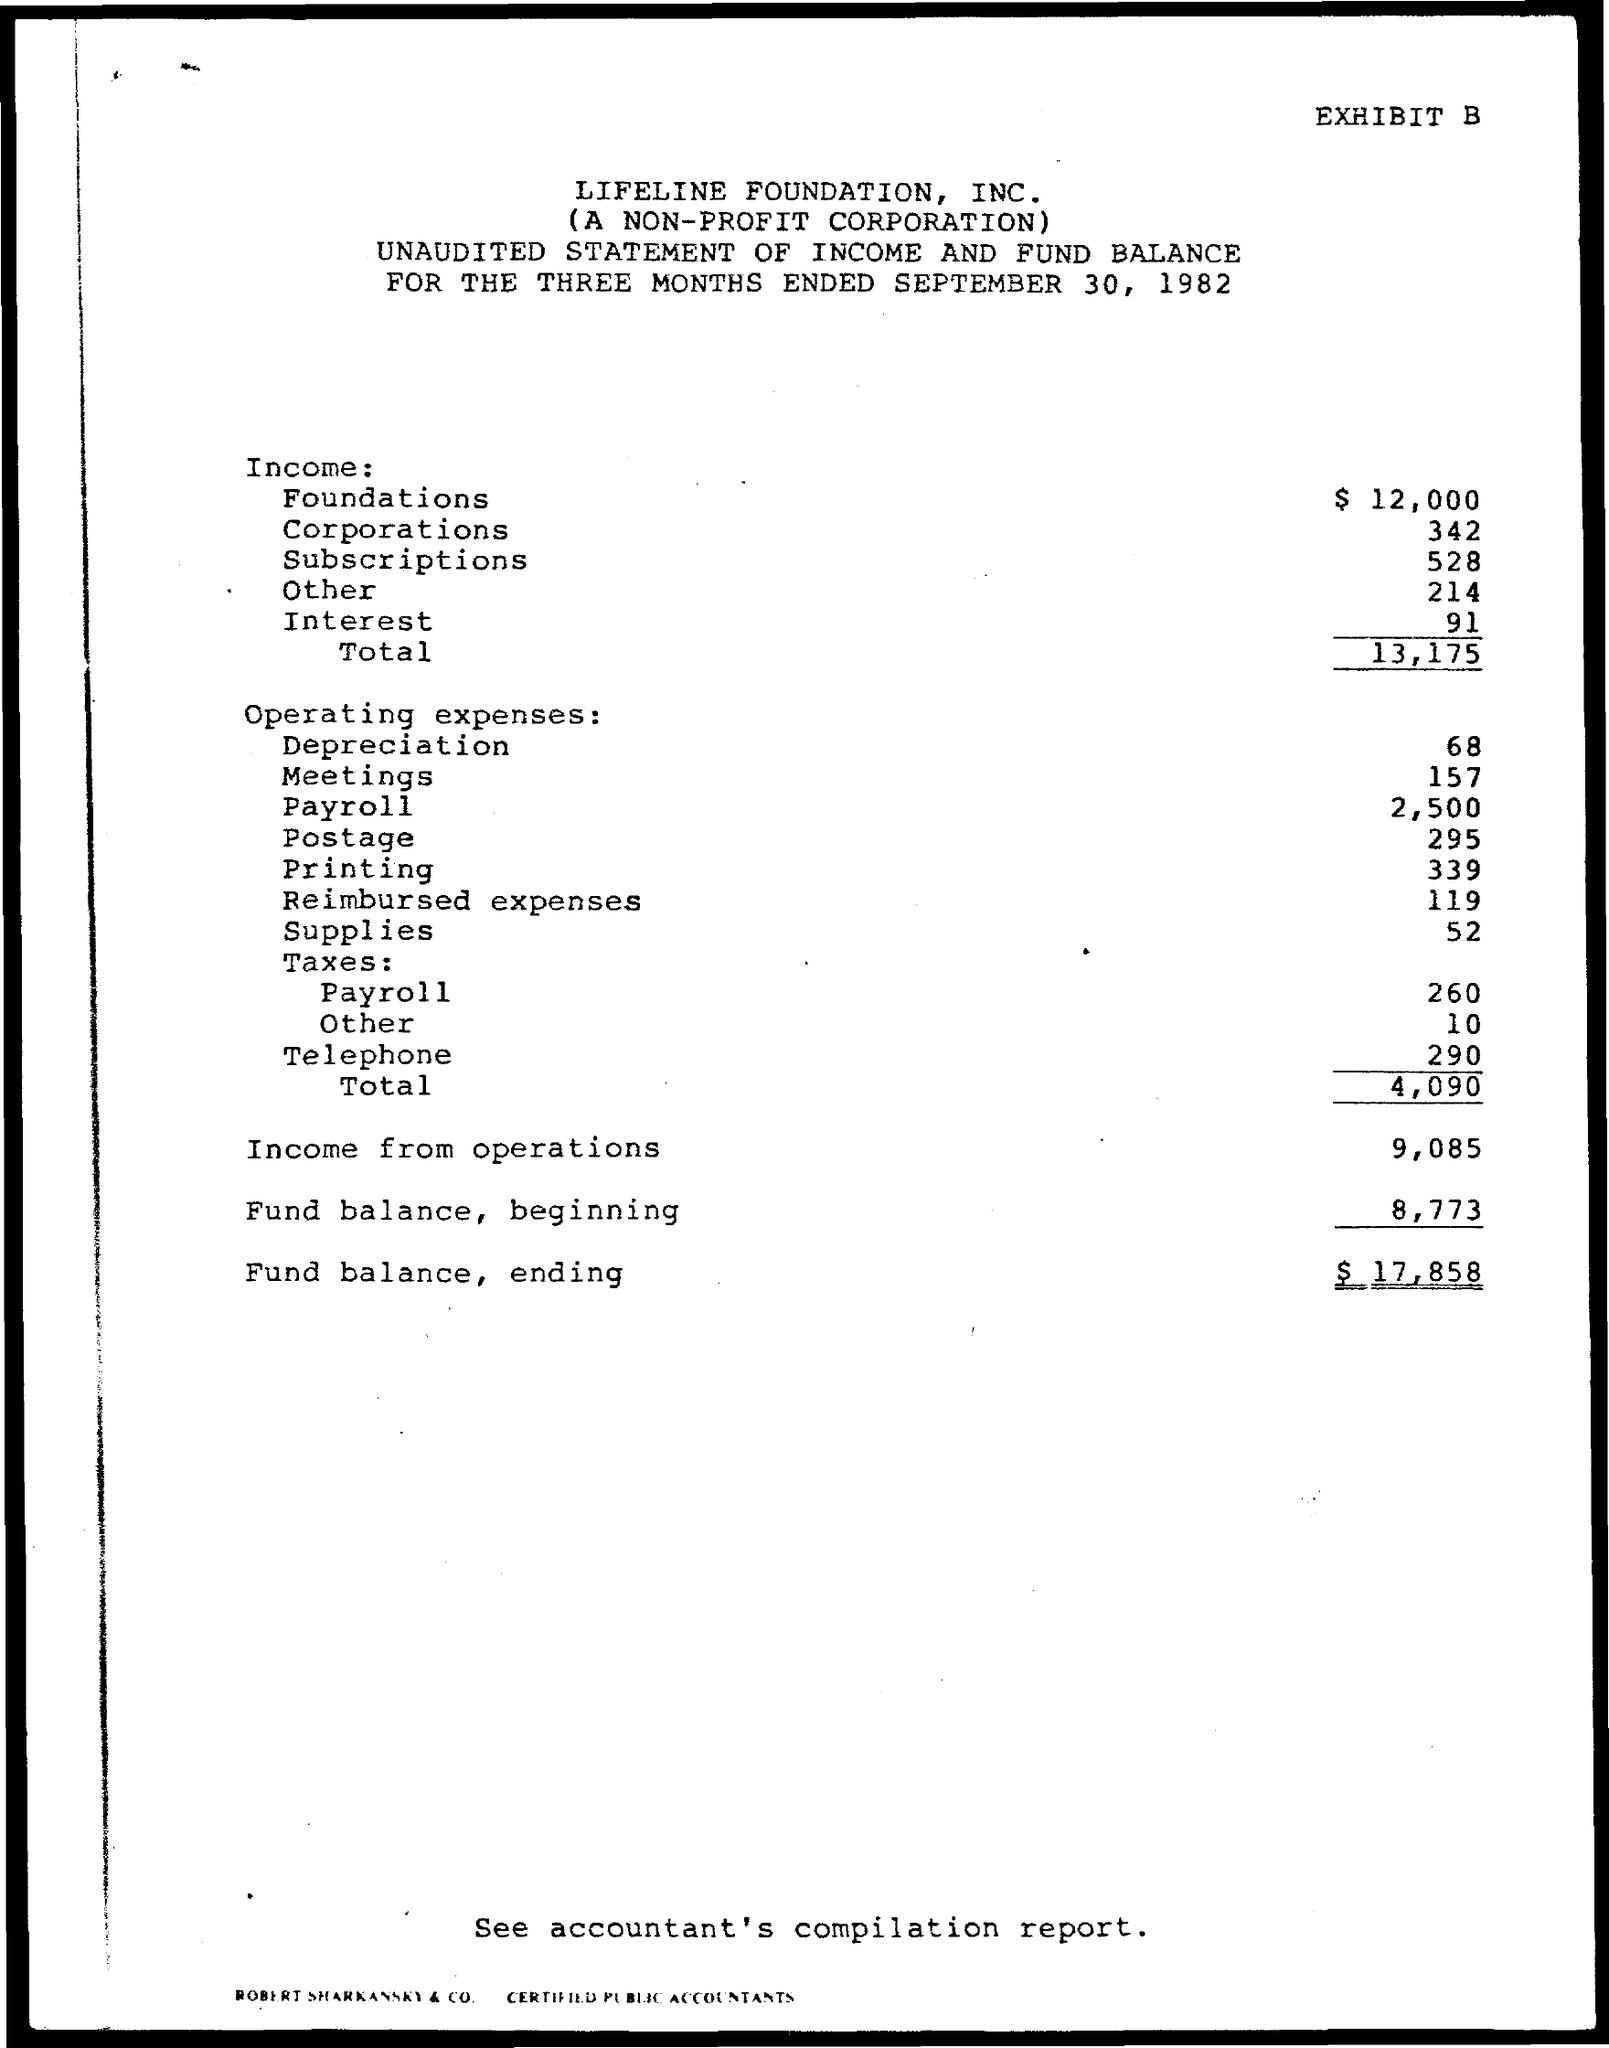What is the Total Income for the three months ended September 30, 1982?
Your answer should be very brief. 13,175. What are the total operating expenses for the three months ended September 30, 1982?
Your response must be concise. $4,090. What is the income from operations for the three months ended September 30, 1982?
Your answer should be compact. $9,085. What is the Fund balance in the beginning for the three months ended September 30, 1982?
Give a very brief answer. 8,773. What is the Fund balance in the ending for the three months ended September 30, 1982?
Provide a succinct answer. $17,858. 